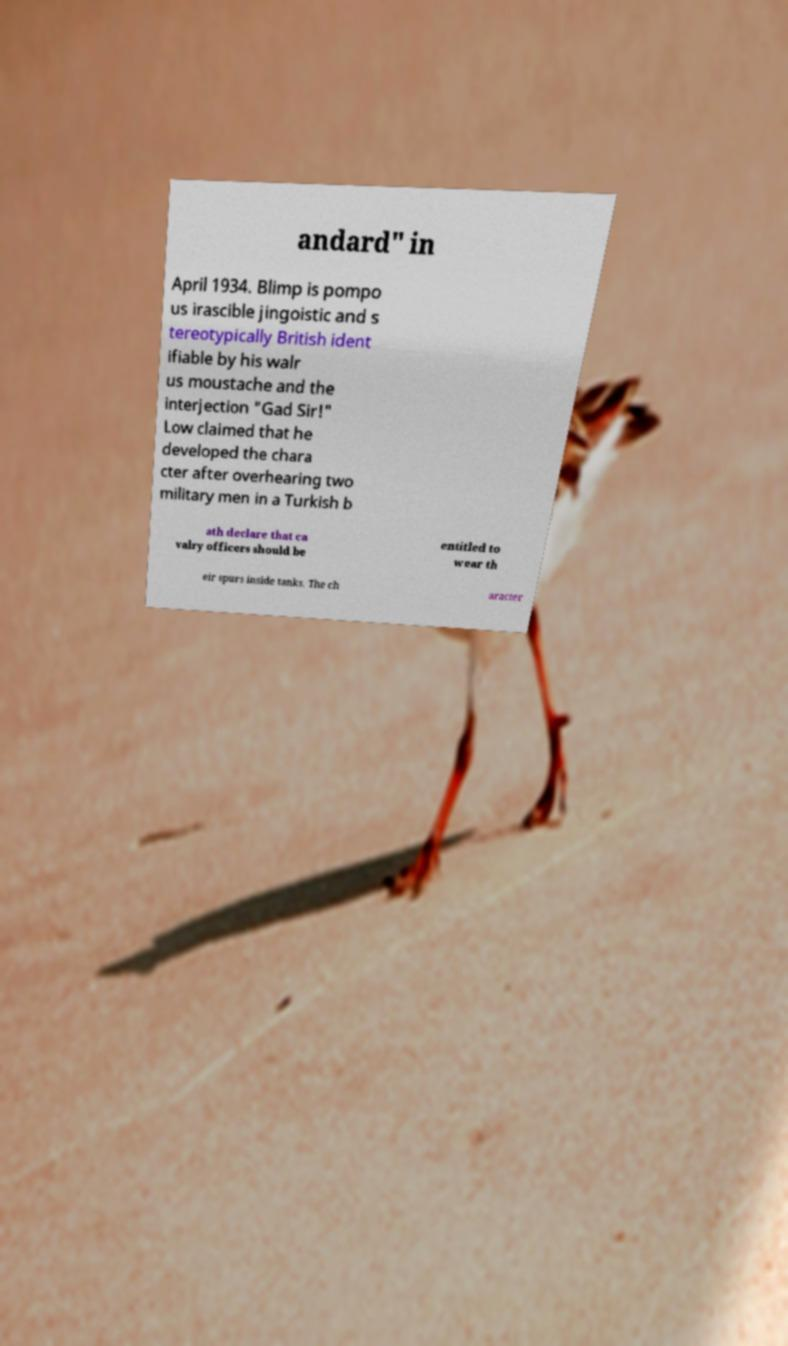Please read and relay the text visible in this image. What does it say? andard" in April 1934. Blimp is pompo us irascible jingoistic and s tereotypically British ident ifiable by his walr us moustache and the interjection "Gad Sir!" Low claimed that he developed the chara cter after overhearing two military men in a Turkish b ath declare that ca valry officers should be entitled to wear th eir spurs inside tanks. The ch aracter 